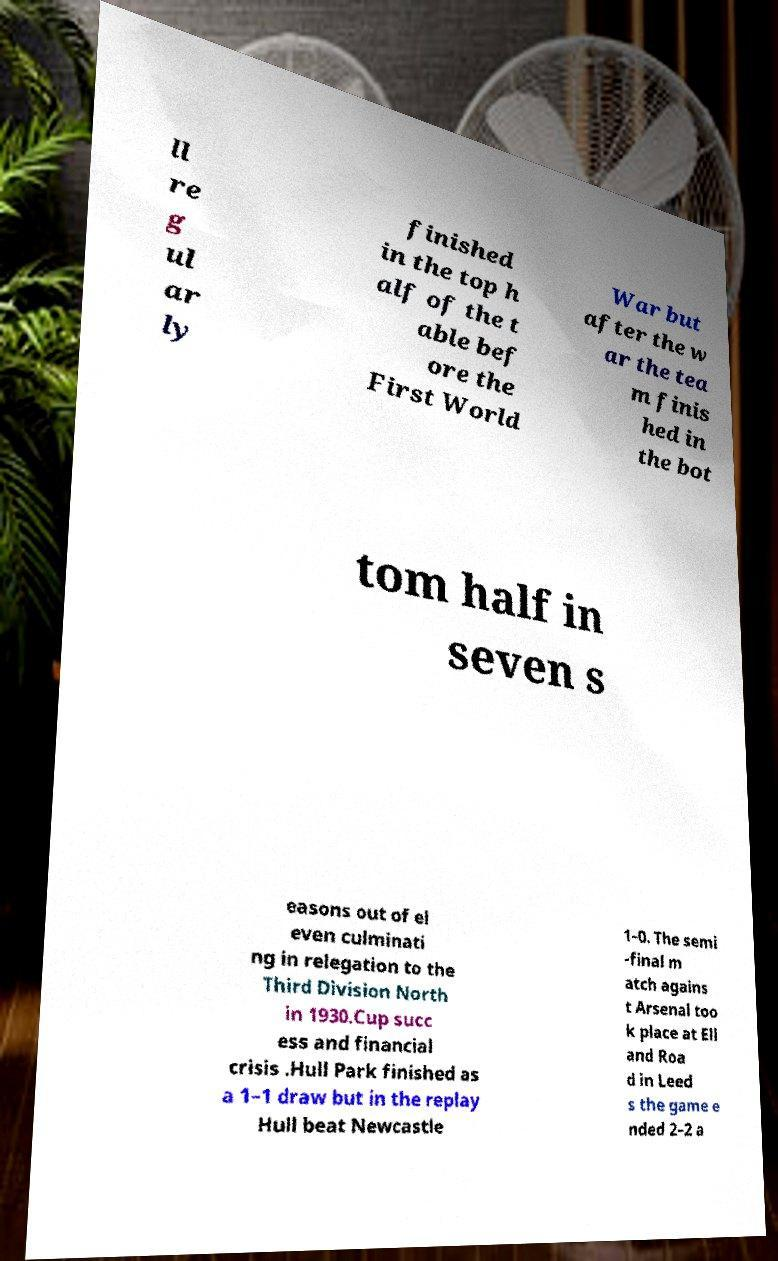Can you accurately transcribe the text from the provided image for me? ll re g ul ar ly finished in the top h alf of the t able bef ore the First World War but after the w ar the tea m finis hed in the bot tom half in seven s easons out of el even culminati ng in relegation to the Third Division North in 1930.Cup succ ess and financial crisis .Hull Park finished as a 1–1 draw but in the replay Hull beat Newcastle 1–0. The semi -final m atch agains t Arsenal too k place at Ell and Roa d in Leed s the game e nded 2–2 a 